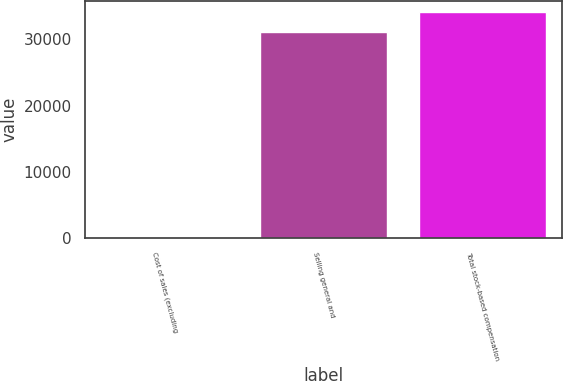Convert chart. <chart><loc_0><loc_0><loc_500><loc_500><bar_chart><fcel>Cost of sales (excluding<fcel>Selling general and<fcel>Total stock-based compensation<nl><fcel>119<fcel>31048<fcel>34152.8<nl></chart> 